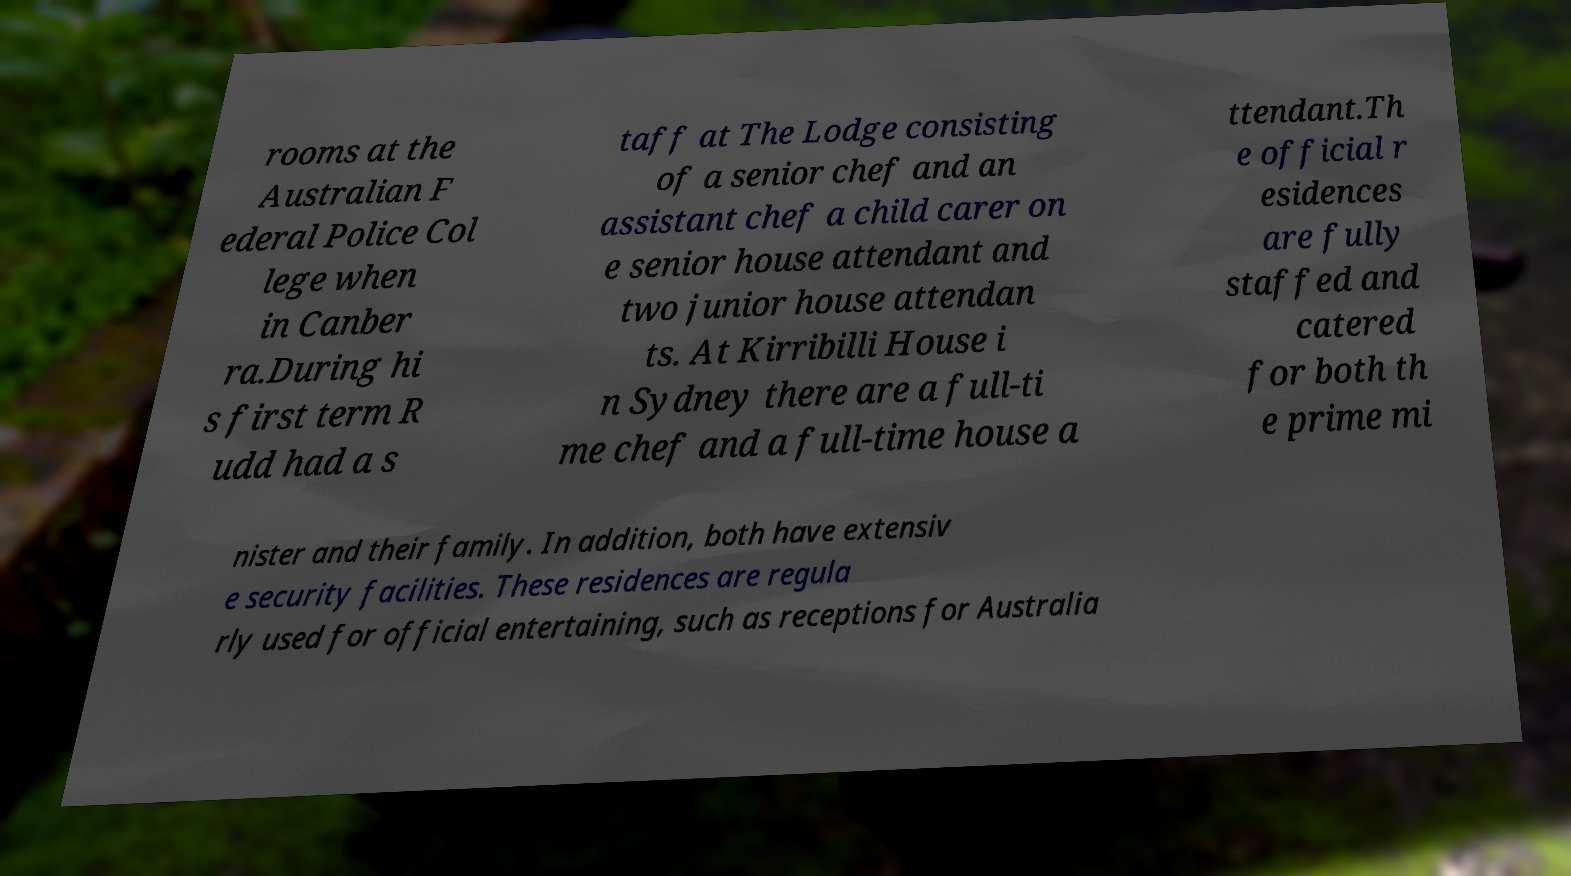Can you accurately transcribe the text from the provided image for me? rooms at the Australian F ederal Police Col lege when in Canber ra.During hi s first term R udd had a s taff at The Lodge consisting of a senior chef and an assistant chef a child carer on e senior house attendant and two junior house attendan ts. At Kirribilli House i n Sydney there are a full-ti me chef and a full-time house a ttendant.Th e official r esidences are fully staffed and catered for both th e prime mi nister and their family. In addition, both have extensiv e security facilities. These residences are regula rly used for official entertaining, such as receptions for Australia 